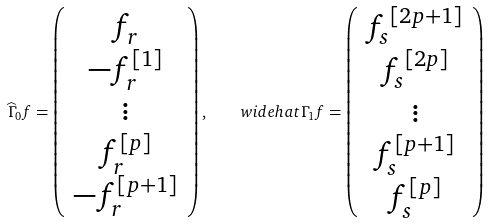<formula> <loc_0><loc_0><loc_500><loc_500>\widehat { \Gamma } _ { 0 } { f } = \left ( \begin{array} { c } f _ { r } \\ - f _ { r } ^ { [ 1 ] } \\ \vdots \\ f ^ { [ p ] } _ { r } \\ - f ^ { [ p + 1 ] } _ { r } \end{array} \right ) , \quad w i d e h a t { \Gamma } _ { 1 } { f } = \left ( \begin{array} { c } { f _ { s } } ^ { [ 2 p + 1 ] } \\ { f _ { s } } ^ { [ 2 p ] } \\ \vdots \\ f _ { s } ^ { [ p + 1 ] } \\ f _ { s } ^ { [ p ] } \end{array} \right )</formula> 